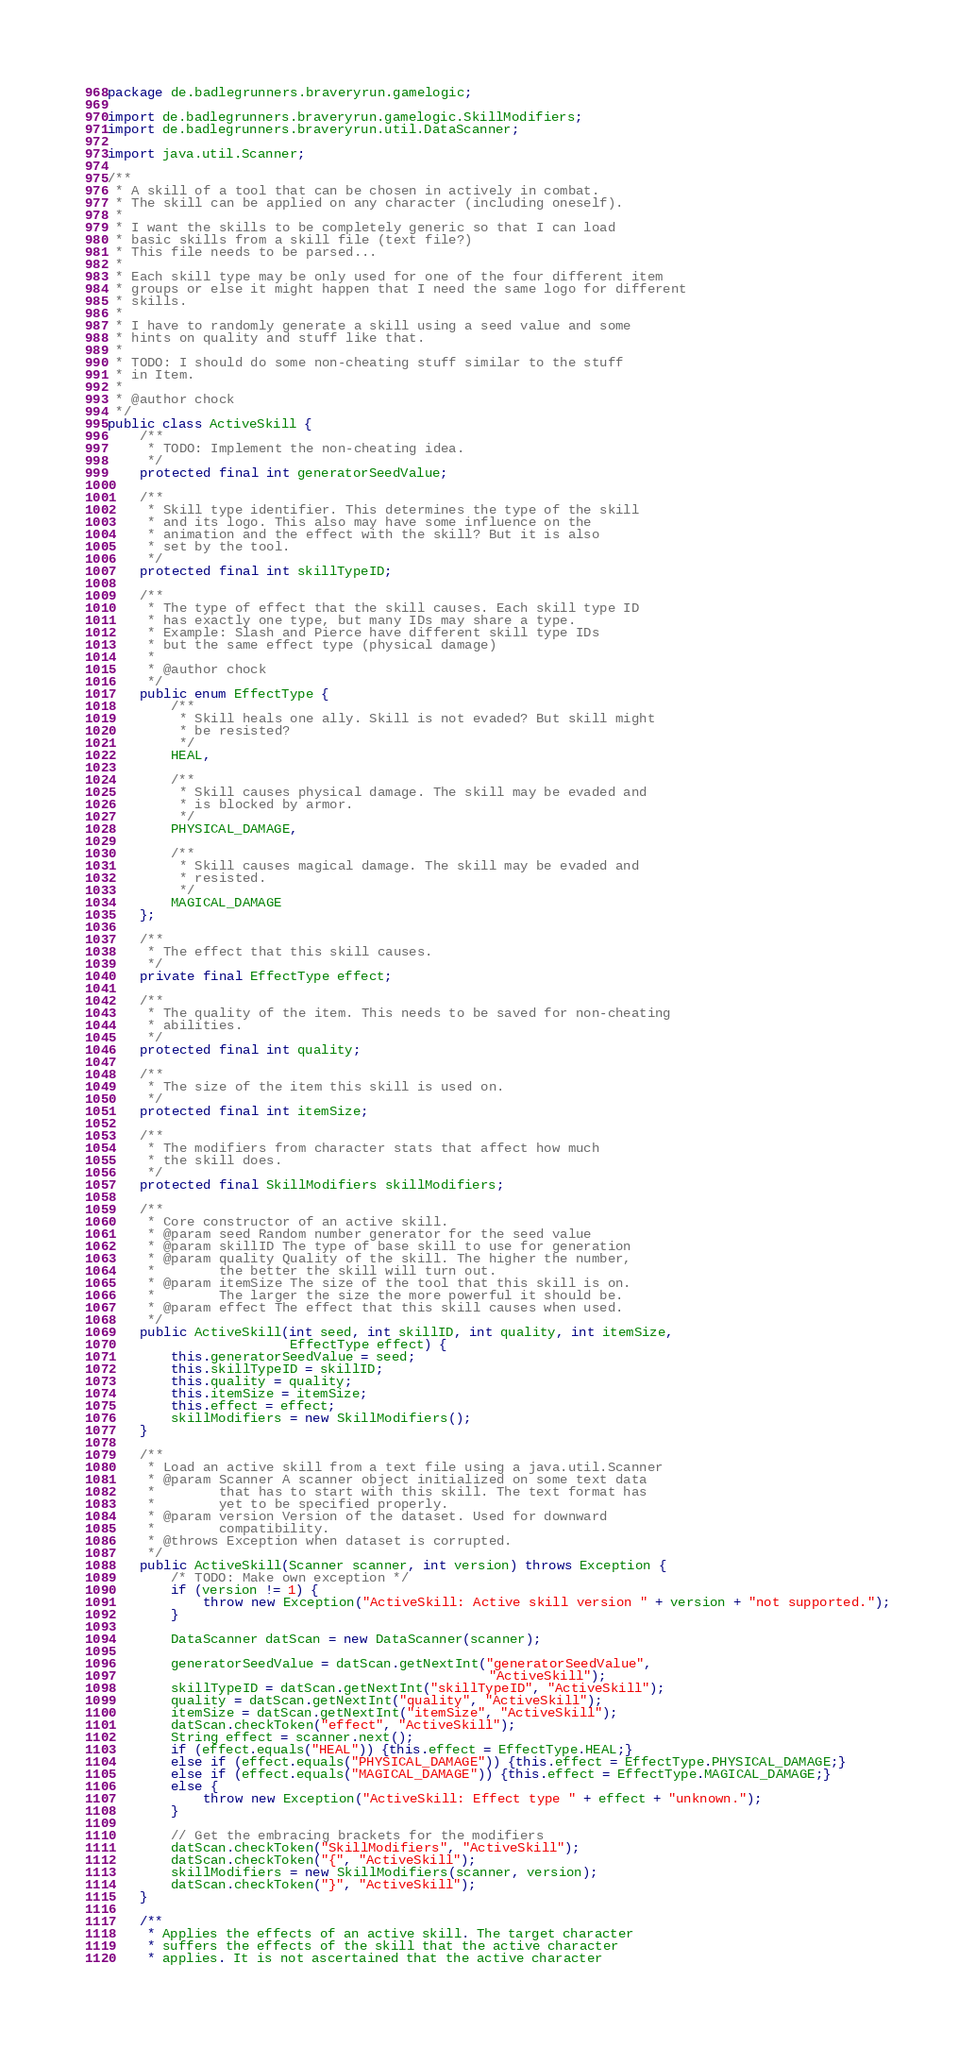Convert code to text. <code><loc_0><loc_0><loc_500><loc_500><_Java_>package de.badlegrunners.braveryrun.gamelogic;

import de.badlegrunners.braveryrun.gamelogic.SkillModifiers;
import de.badlegrunners.braveryrun.util.DataScanner;

import java.util.Scanner;

/**
 * A skill of a tool that can be chosen in actively in combat.
 * The skill can be applied on any character (including oneself).
 * 
 * I want the skills to be completely generic so that I can load
 * basic skills from a skill file (text file?)
 * This file needs to be parsed...
 * 
 * Each skill type may be only used for one of the four different item
 * groups or else it might happen that I need the same logo for different
 * skills.
 * 
 * I have to randomly generate a skill using a seed value and some
 * hints on quality and stuff like that.
 * 
 * TODO: I should do some non-cheating stuff similar to the stuff
 * in Item.
 * 
 * @author chock
 */
public class ActiveSkill {
	/**
	 * TODO: Implement the non-cheating idea.
	 */
	protected final int generatorSeedValue;
	
	/**
	 * Skill type identifier. This determines the type of the skill
	 * and its logo. This also may have some influence on the
	 * animation and the effect with the skill? But it is also
	 * set by the tool.
	 */
	protected final int skillTypeID;
	
	/**
	 * The type of effect that the skill causes. Each skill type ID
	 * has exactly one type, but many IDs may share a type.
	 * Example: Slash and Pierce have different skill type IDs
	 * but the same effect type (physical damage)
	 * 
	 * @author chock
	 */
	public enum EffectType {
		/**
		 * Skill heals one ally. Skill is not evaded? But skill might
		 * be resisted?
		 */
		HEAL,

		/**
		 * Skill causes physical damage. The skill may be evaded and
		 * is blocked by armor.
		 */
		PHYSICAL_DAMAGE,
		
		/**
		 * Skill causes magical damage. The skill may be evaded and
		 * resisted.
		 */
		MAGICAL_DAMAGE
	};
	
	/**
	 * The effect that this skill causes.
	 */
	private final EffectType effect;
	
	/**
	 * The quality of the item. This needs to be saved for non-cheating
	 * abilities.
	 */
	protected final int quality;
	
	/**
	 * The size of the item this skill is used on.
	 */
	protected final int itemSize;
	
	/**
	 * The modifiers from character stats that affect how much
	 * the skill does.
	 */
	protected final SkillModifiers skillModifiers;
	
	/**
	 * Core constructor of an active skill.
	 * @param seed Random number generator for the seed value
	 * @param skillID The type of base skill to use for generation
	 * @param quality Quality of the skill. The higher the number,
	 * 		  the better the skill will turn out.
	 * @param itemSize The size of the tool that this skill is on.
	 * 		  The larger the size the more powerful it should be.
	 * @param effect The effect that this skill causes when used.
	 */
	public ActiveSkill(int seed, int skillID, int quality, int itemSize,
					   EffectType effect) {
		this.generatorSeedValue = seed;
		this.skillTypeID = skillID;
		this.quality = quality;
		this.itemSize = itemSize;
		this.effect = effect;
		skillModifiers = new SkillModifiers();
	}
	
	/**
	 * Load an active skill from a text file using a java.util.Scanner
	 * @param Scanner A scanner object initialized on some text data
	 * 		  that has to start with this skill. The text format has
	 *        yet to be specified properly.
	 * @param version Version of the dataset. Used for downward
	 * 		  compatibility.
	 * @throws Exception when dataset is corrupted.
	 */
	public ActiveSkill(Scanner scanner, int version) throws Exception {
		/* TODO: Make own exception */
		if (version != 1) {
			throw new Exception("ActiveSkill: Active skill version " + version + "not supported.");
		}

		DataScanner datScan = new DataScanner(scanner);
		
		generatorSeedValue = datScan.getNextInt("generatorSeedValue",
												"ActiveSkill");
		skillTypeID = datScan.getNextInt("skillTypeID", "ActiveSkill");
		quality = datScan.getNextInt("quality", "ActiveSkill");
		itemSize = datScan.getNextInt("itemSize", "ActiveSkill");
		datScan.checkToken("effect", "ActiveSkill");
		String effect = scanner.next();
		if (effect.equals("HEAL")) {this.effect = EffectType.HEAL;}
		else if (effect.equals("PHYSICAL_DAMAGE")) {this.effect = EffectType.PHYSICAL_DAMAGE;}
		else if (effect.equals("MAGICAL_DAMAGE")) {this.effect = EffectType.MAGICAL_DAMAGE;}
		else {
			throw new Exception("ActiveSkill: Effect type " + effect + "unknown.");
		}
		
		// Get the embracing brackets for the modifiers
		datScan.checkToken("SkillModifiers", "ActiveSkill");
		datScan.checkToken("{", "ActiveSkill");
		skillModifiers = new SkillModifiers(scanner, version);
		datScan.checkToken("}", "ActiveSkill");
	}

	/**
	 * Applies the effects of an active skill. The target character
	 * suffers the effects of the skill that the active character
	 * applies. It is not ascertained that the active character</code> 